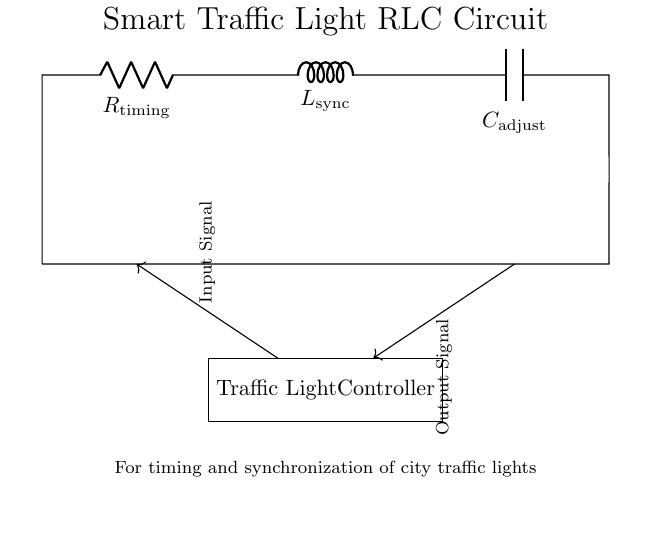What are the components in this circuit? The circuit consists of a resistor, an inductor, and a capacitor, specifically denoted as R1, L1, and C1.
Answer: Resistor, Inductor, Capacitor What is the function of R1 in this circuit? R1 is labeled as R_timing in the diagram, indicating its role in controlling the timing aspects of the traffic light system.
Answer: Timing What does L1 represent in this circuit? The inductor L1 is labeled as L_sync, which suggests it is used for synchronization in the traffic light system.
Answer: Synchronization How many main components are in this circuit schematic? The circuit contains three main passive components: a resistor, an inductor, and a capacitor.
Answer: Three What type of circuit is this? This circuit is classified as an RLC circuit because it includes a resistor, an inductor, and a capacitor in series.
Answer: RLC circuit What role does C1 serve in the traffic light system? C1 is denoted as C_adjust, indicating it functions for adjusting the timing or response characteristics of the circuit.
Answer: Adjustment What does the arrow represent between the controller and the circuit? The arrows signify the signal flow, with inputs to the traffic light controller and outputs from it based on circuit operation.
Answer: Signal flow 